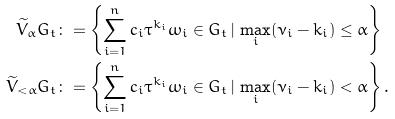Convert formula to latex. <formula><loc_0><loc_0><loc_500><loc_500>\widetilde { V } _ { \alpha } G _ { t } & \colon = \left \{ \sum _ { i = 1 } ^ { n } c _ { i } \tau ^ { k _ { i } } \omega _ { i } \in G _ { t } \, | \, \max _ { i } ( \nu _ { i } - k _ { i } ) \leq \alpha \right \} \\ \widetilde { V } _ { < \alpha } G _ { t } & \colon = \left \{ \sum _ { i = 1 } ^ { n } c _ { i } \tau ^ { k _ { i } } \omega _ { i } \in G _ { t } \, | \, \max _ { i } ( \nu _ { i } - k _ { i } ) < \alpha \right \} .</formula> 